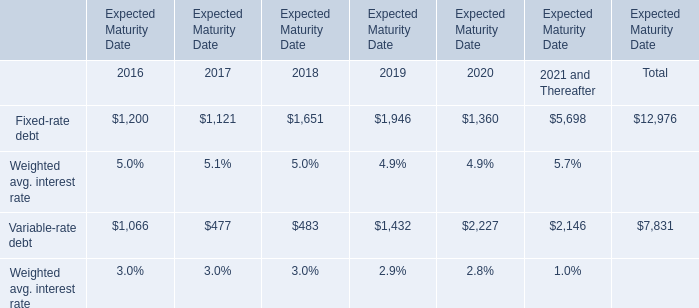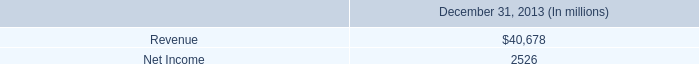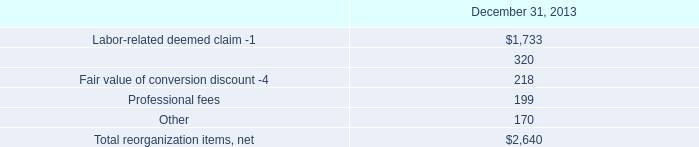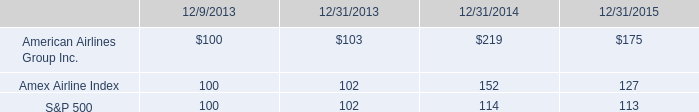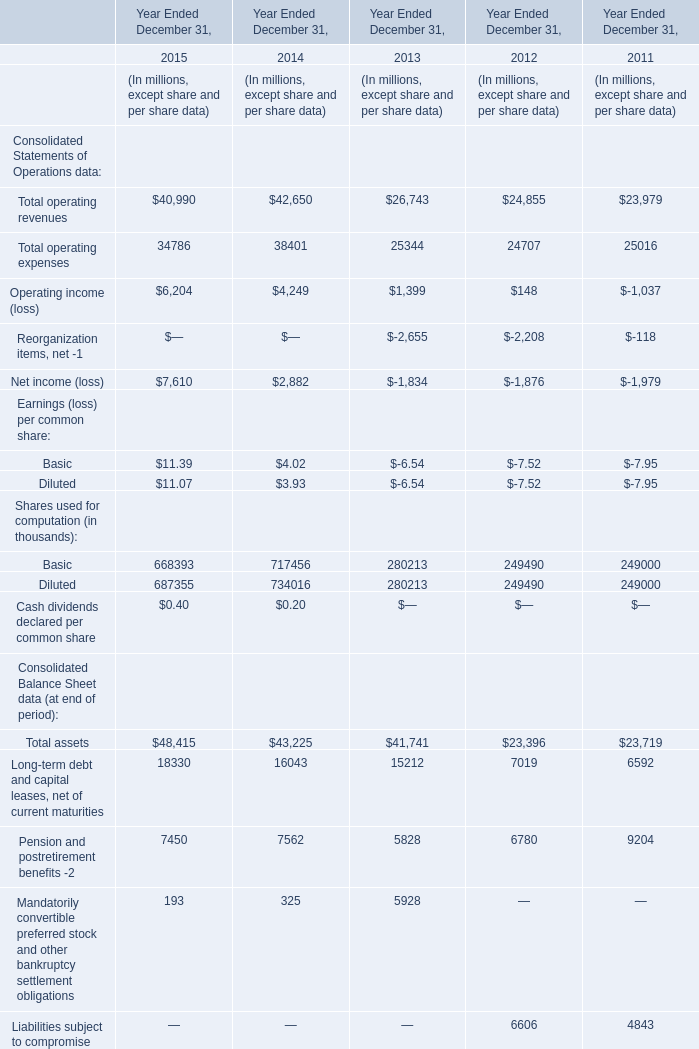what was the 4 year return of american airlines group inc . common stock? 
Computations: ((175 - 100) / 100)
Answer: 0.75. 